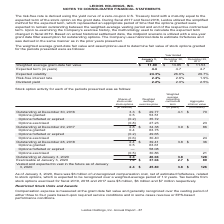According to Leidos Holdings's financial document, Which model is used to value company's stock option? Based on the financial document, the answer is Black-Scholes- Merton option-pricing model. Also, When did the Company ceased the usage of peer group volatility? According to the financial document, During fiscal 2017. The relevant text states: "ected term of the stock option on the grant date. During fiscal 2017 and fiscal 2018, Leidos utilized the simplified method for the expected term, which represented an..." Also, What was the Weighted average grant-date fair value in 2018 and 2017 respectively? The document shows two values: $13.85 and $11.53. From the document: "d average grant-date fair value $ 11.89 $ 13.85 $ 11.53 Expected term (in years) 4.4 4.7 4.7 Expected volatility 24.3% 26.6% 29.7% Risk-free interest ..." Additionally, In which year was Weighted average grant-date fair value less than 13.00? The document shows two values: 2020 and 2017. Locate and analyze weighted average grant-date fair value in row 4. From the document: "January 3, 2020 December 28, 2018 December 29, 2017 Weighted average grant-date fair value $ 11.89 $ 13.85 $ 11.53 Expected term (in years) 4.4 4.7 4...." Also, can you calculate: What was the average Expected volatility in 2018 and 2017? To answer this question, I need to perform calculations using the financial data. The calculation is: (26.6 + 29.7) / 2, which equals 28.15 (percentage). This is based on the information: "ears) 4.4 4.7 4.7 Expected volatility 24.3% 26.6% 29.7% Risk-free interest rate 2.4% 2.6% 1.9% Dividend yield 2.2% 2.0% 2.5% (in years) 4.4 4.7 4.7 Expected volatility 24.3% 26.6% 29.7% Risk-free inte..." The key data points involved are: 26.6, 29.7. Also, can you calculate: What was the change in the Risk-free interest rate from 2017 to 2018? Based on the calculation: 2.6 - 1.9, the result is 0.7 (percentage). This is based on the information: "ty 24.3% 26.6% 29.7% Risk-free interest rate 2.4% 2.6% 1.9% Dividend yield 2.2% 2.0% 2.5% .3% 26.6% 29.7% Risk-free interest rate 2.4% 2.6% 1.9% Dividend yield 2.2% 2.0% 2.5%..." The key data points involved are: 1.9, 2.6. 